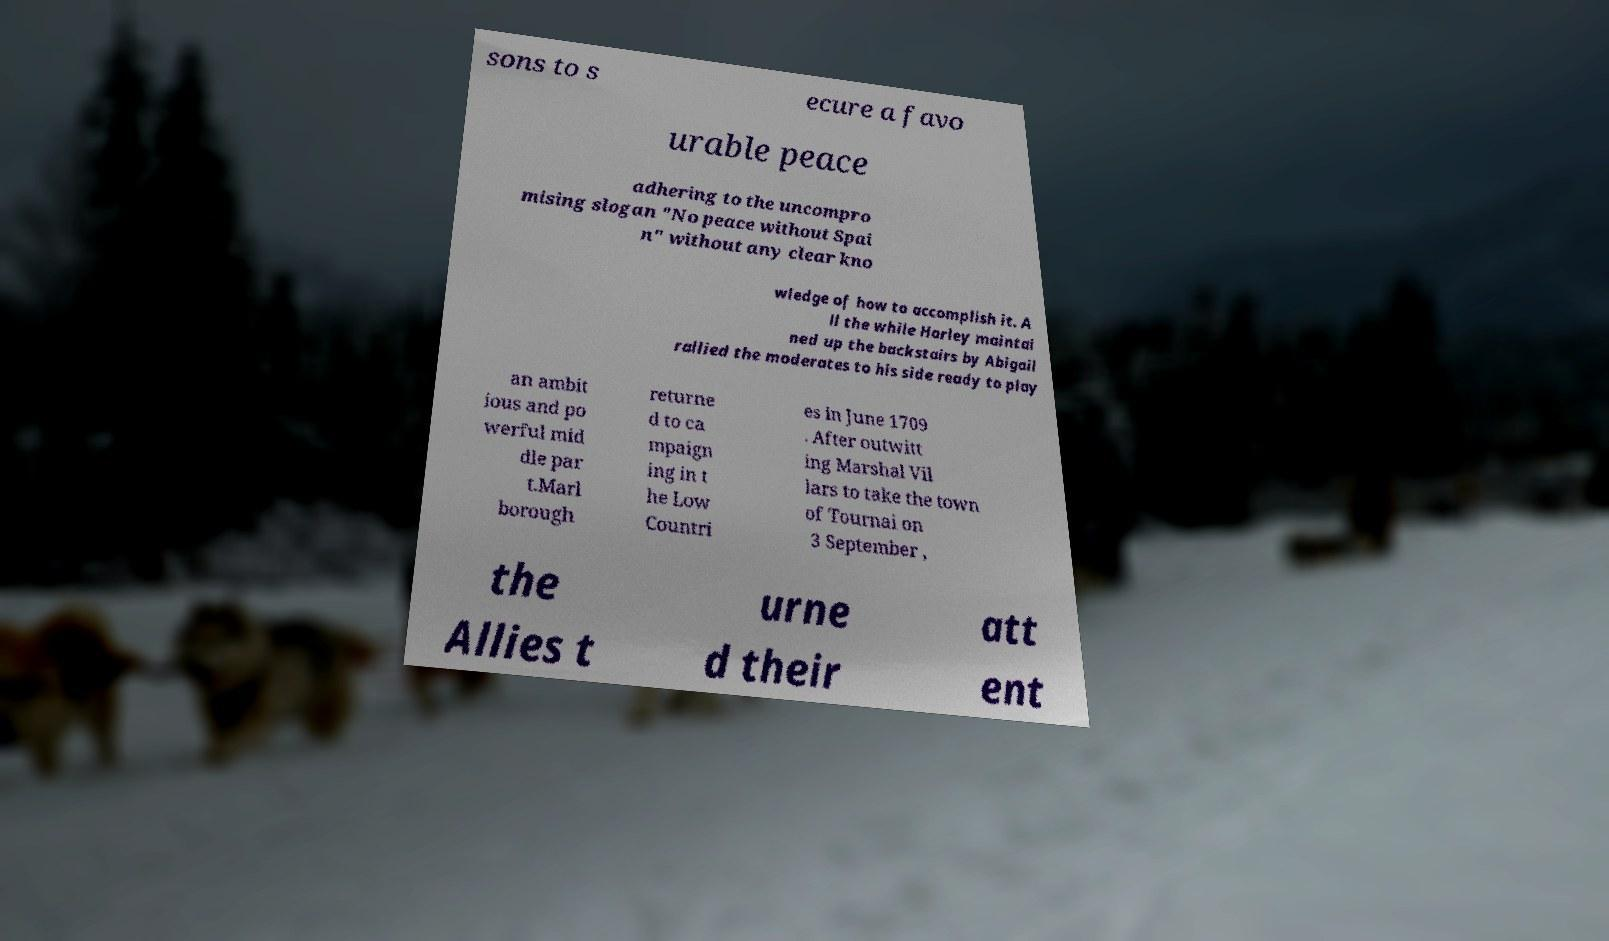What messages or text are displayed in this image? I need them in a readable, typed format. sons to s ecure a favo urable peace adhering to the uncompro mising slogan "No peace without Spai n" without any clear kno wledge of how to accomplish it. A ll the while Harley maintai ned up the backstairs by Abigail rallied the moderates to his side ready to play an ambit ious and po werful mid dle par t.Marl borough returne d to ca mpaign ing in t he Low Countri es in June 1709 . After outwitt ing Marshal Vil lars to take the town of Tournai on 3 September , the Allies t urne d their att ent 